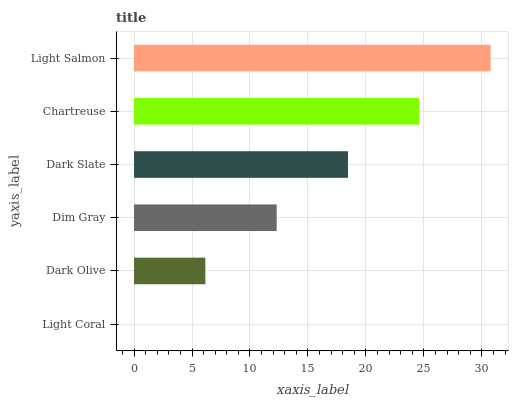Is Light Coral the minimum?
Answer yes or no. Yes. Is Light Salmon the maximum?
Answer yes or no. Yes. Is Dark Olive the minimum?
Answer yes or no. No. Is Dark Olive the maximum?
Answer yes or no. No. Is Dark Olive greater than Light Coral?
Answer yes or no. Yes. Is Light Coral less than Dark Olive?
Answer yes or no. Yes. Is Light Coral greater than Dark Olive?
Answer yes or no. No. Is Dark Olive less than Light Coral?
Answer yes or no. No. Is Dark Slate the high median?
Answer yes or no. Yes. Is Dim Gray the low median?
Answer yes or no. Yes. Is Dim Gray the high median?
Answer yes or no. No. Is Chartreuse the low median?
Answer yes or no. No. 